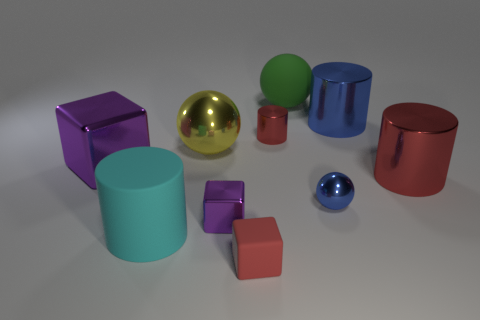Are there any other things that have the same size as the blue cylinder?
Give a very brief answer. Yes. There is a large shiny block; is its color the same as the shiny cylinder that is in front of the tiny red shiny object?
Your response must be concise. No. Is the number of tiny red cylinders that are on the left side of the yellow metal sphere the same as the number of large cyan matte things?
Ensure brevity in your answer.  No. What number of other things have the same size as the cyan rubber object?
Make the answer very short. 5. What is the shape of the small metallic object that is the same color as the small rubber thing?
Your response must be concise. Cylinder. Are any large red objects visible?
Make the answer very short. Yes. Is the shape of the tiny purple metallic object on the left side of the big green matte thing the same as the matte thing that is on the left side of the matte cube?
Offer a terse response. No. How many small things are cyan things or rubber spheres?
Make the answer very short. 0. What is the shape of the small red object that is made of the same material as the small blue thing?
Ensure brevity in your answer.  Cylinder. Is the large cyan matte object the same shape as the large red shiny thing?
Make the answer very short. Yes. 